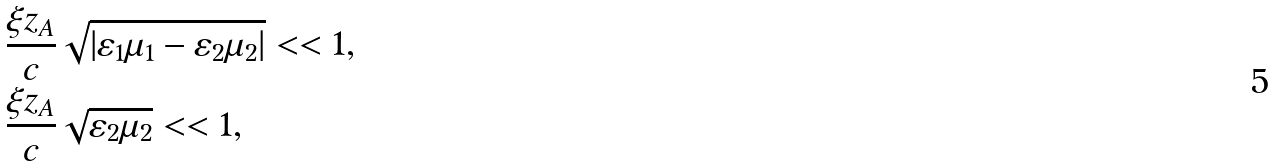Convert formula to latex. <formula><loc_0><loc_0><loc_500><loc_500>& \frac { \xi z _ { A } } { c } \sqrt { \left | \varepsilon _ { 1 } \mu _ { 1 } - \varepsilon _ { 2 } \mu _ { 2 } \right | } < < 1 , \\ & \frac { \xi z _ { A } } { c } \sqrt { \varepsilon _ { 2 } \mu _ { 2 } } < < 1 ,</formula> 